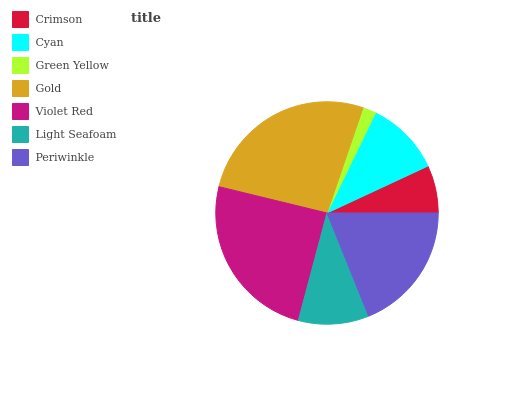Is Green Yellow the minimum?
Answer yes or no. Yes. Is Gold the maximum?
Answer yes or no. Yes. Is Cyan the minimum?
Answer yes or no. No. Is Cyan the maximum?
Answer yes or no. No. Is Cyan greater than Crimson?
Answer yes or no. Yes. Is Crimson less than Cyan?
Answer yes or no. Yes. Is Crimson greater than Cyan?
Answer yes or no. No. Is Cyan less than Crimson?
Answer yes or no. No. Is Cyan the high median?
Answer yes or no. Yes. Is Cyan the low median?
Answer yes or no. Yes. Is Green Yellow the high median?
Answer yes or no. No. Is Violet Red the low median?
Answer yes or no. No. 